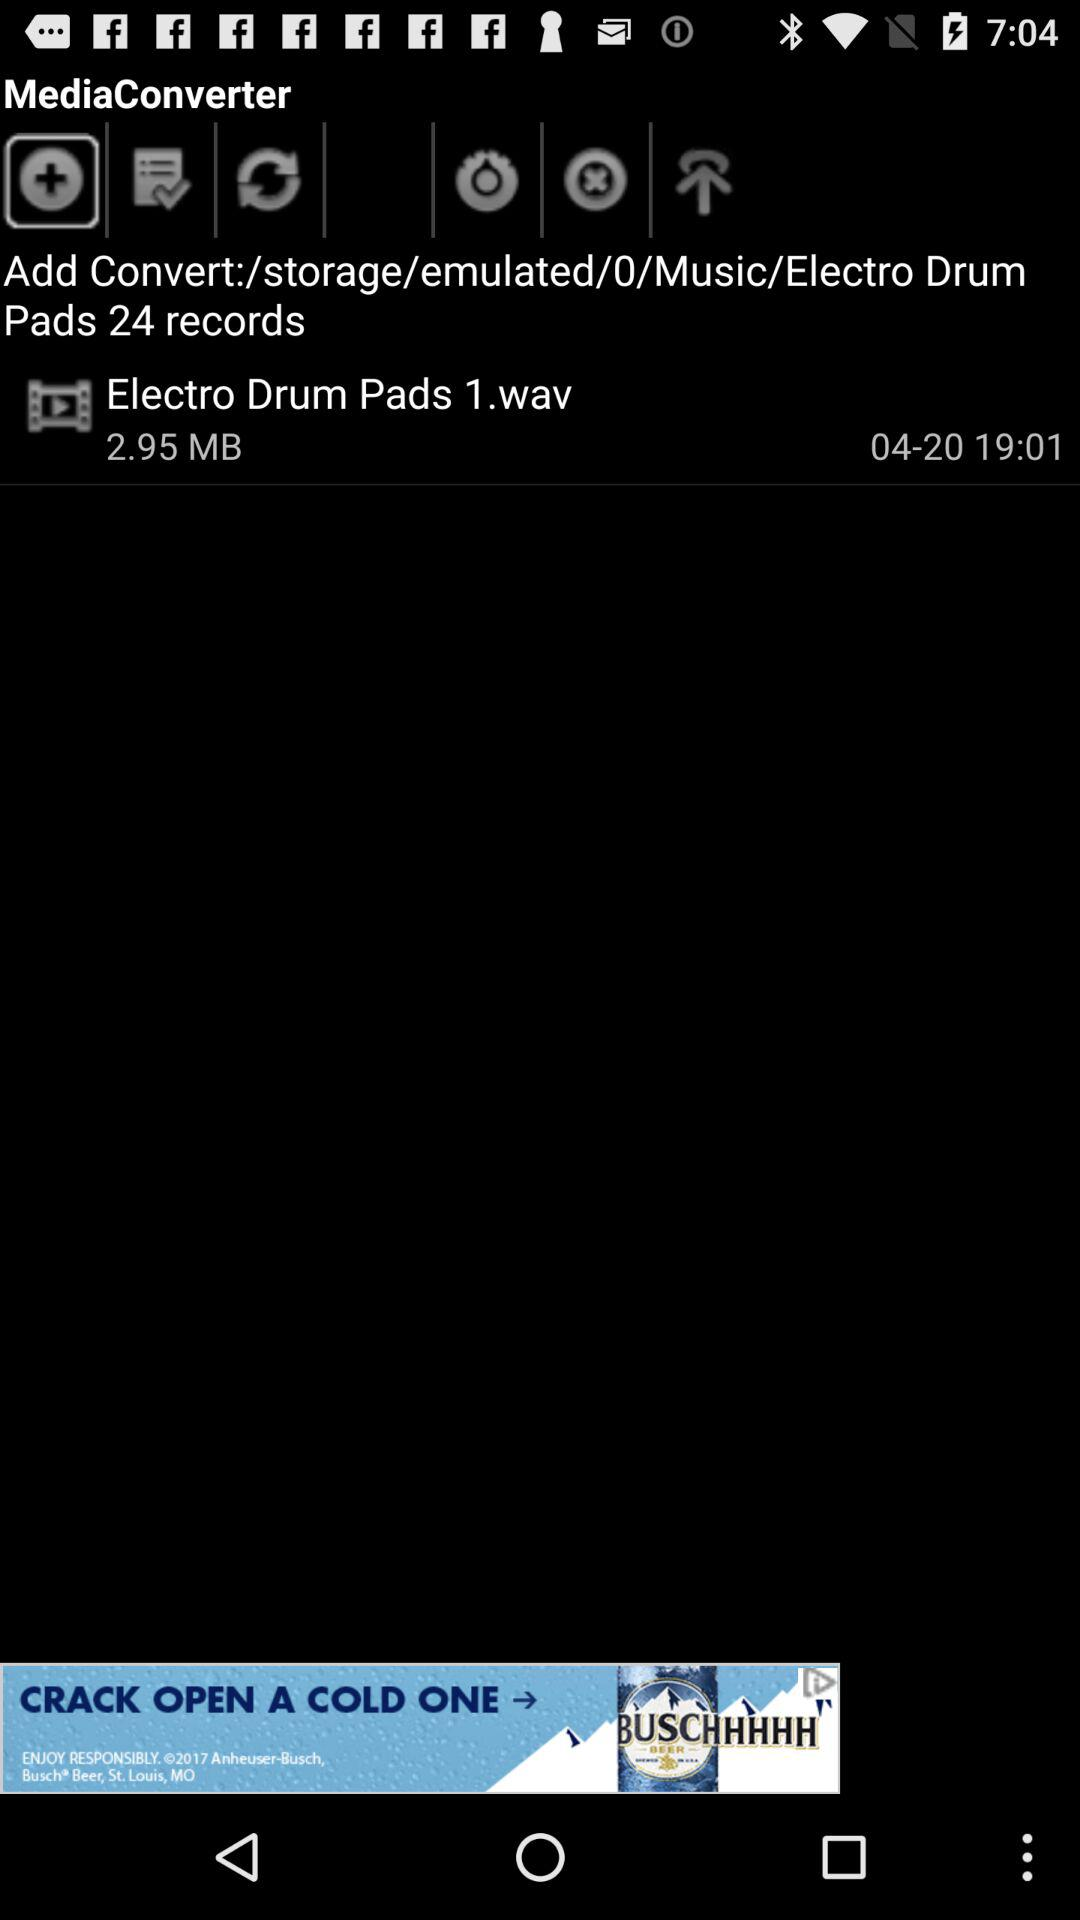What is the size of the "Electro Drum Pads"? The size of the "Electro Drum Pads" is 2.95 MB. 